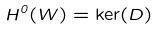Convert formula to latex. <formula><loc_0><loc_0><loc_500><loc_500>H ^ { 0 } ( W ) = \ker ( D )</formula> 